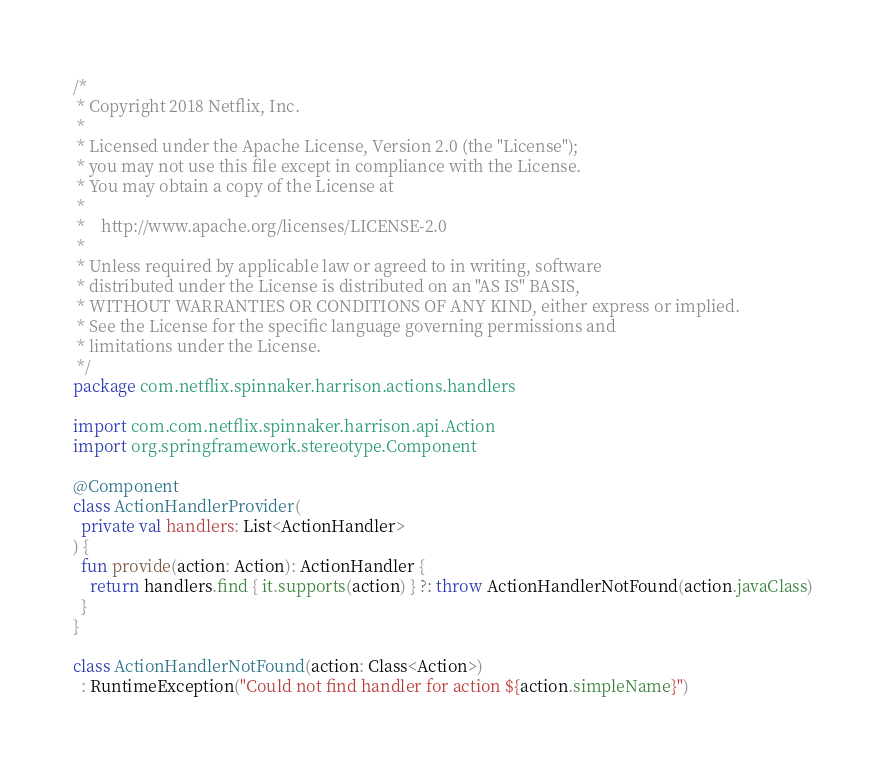<code> <loc_0><loc_0><loc_500><loc_500><_Kotlin_>/*
 * Copyright 2018 Netflix, Inc.
 *
 * Licensed under the Apache License, Version 2.0 (the "License");
 * you may not use this file except in compliance with the License.
 * You may obtain a copy of the License at
 *
 *    http://www.apache.org/licenses/LICENSE-2.0
 *
 * Unless required by applicable law or agreed to in writing, software
 * distributed under the License is distributed on an "AS IS" BASIS,
 * WITHOUT WARRANTIES OR CONDITIONS OF ANY KIND, either express or implied.
 * See the License for the specific language governing permissions and
 * limitations under the License.
 */
package com.netflix.spinnaker.harrison.actions.handlers

import com.com.netflix.spinnaker.harrison.api.Action
import org.springframework.stereotype.Component

@Component
class ActionHandlerProvider(
  private val handlers: List<ActionHandler>
) {
  fun provide(action: Action): ActionHandler {
    return handlers.find { it.supports(action) } ?: throw ActionHandlerNotFound(action.javaClass)
  }
}

class ActionHandlerNotFound(action: Class<Action>)
  : RuntimeException("Could not find handler for action ${action.simpleName}")
</code> 